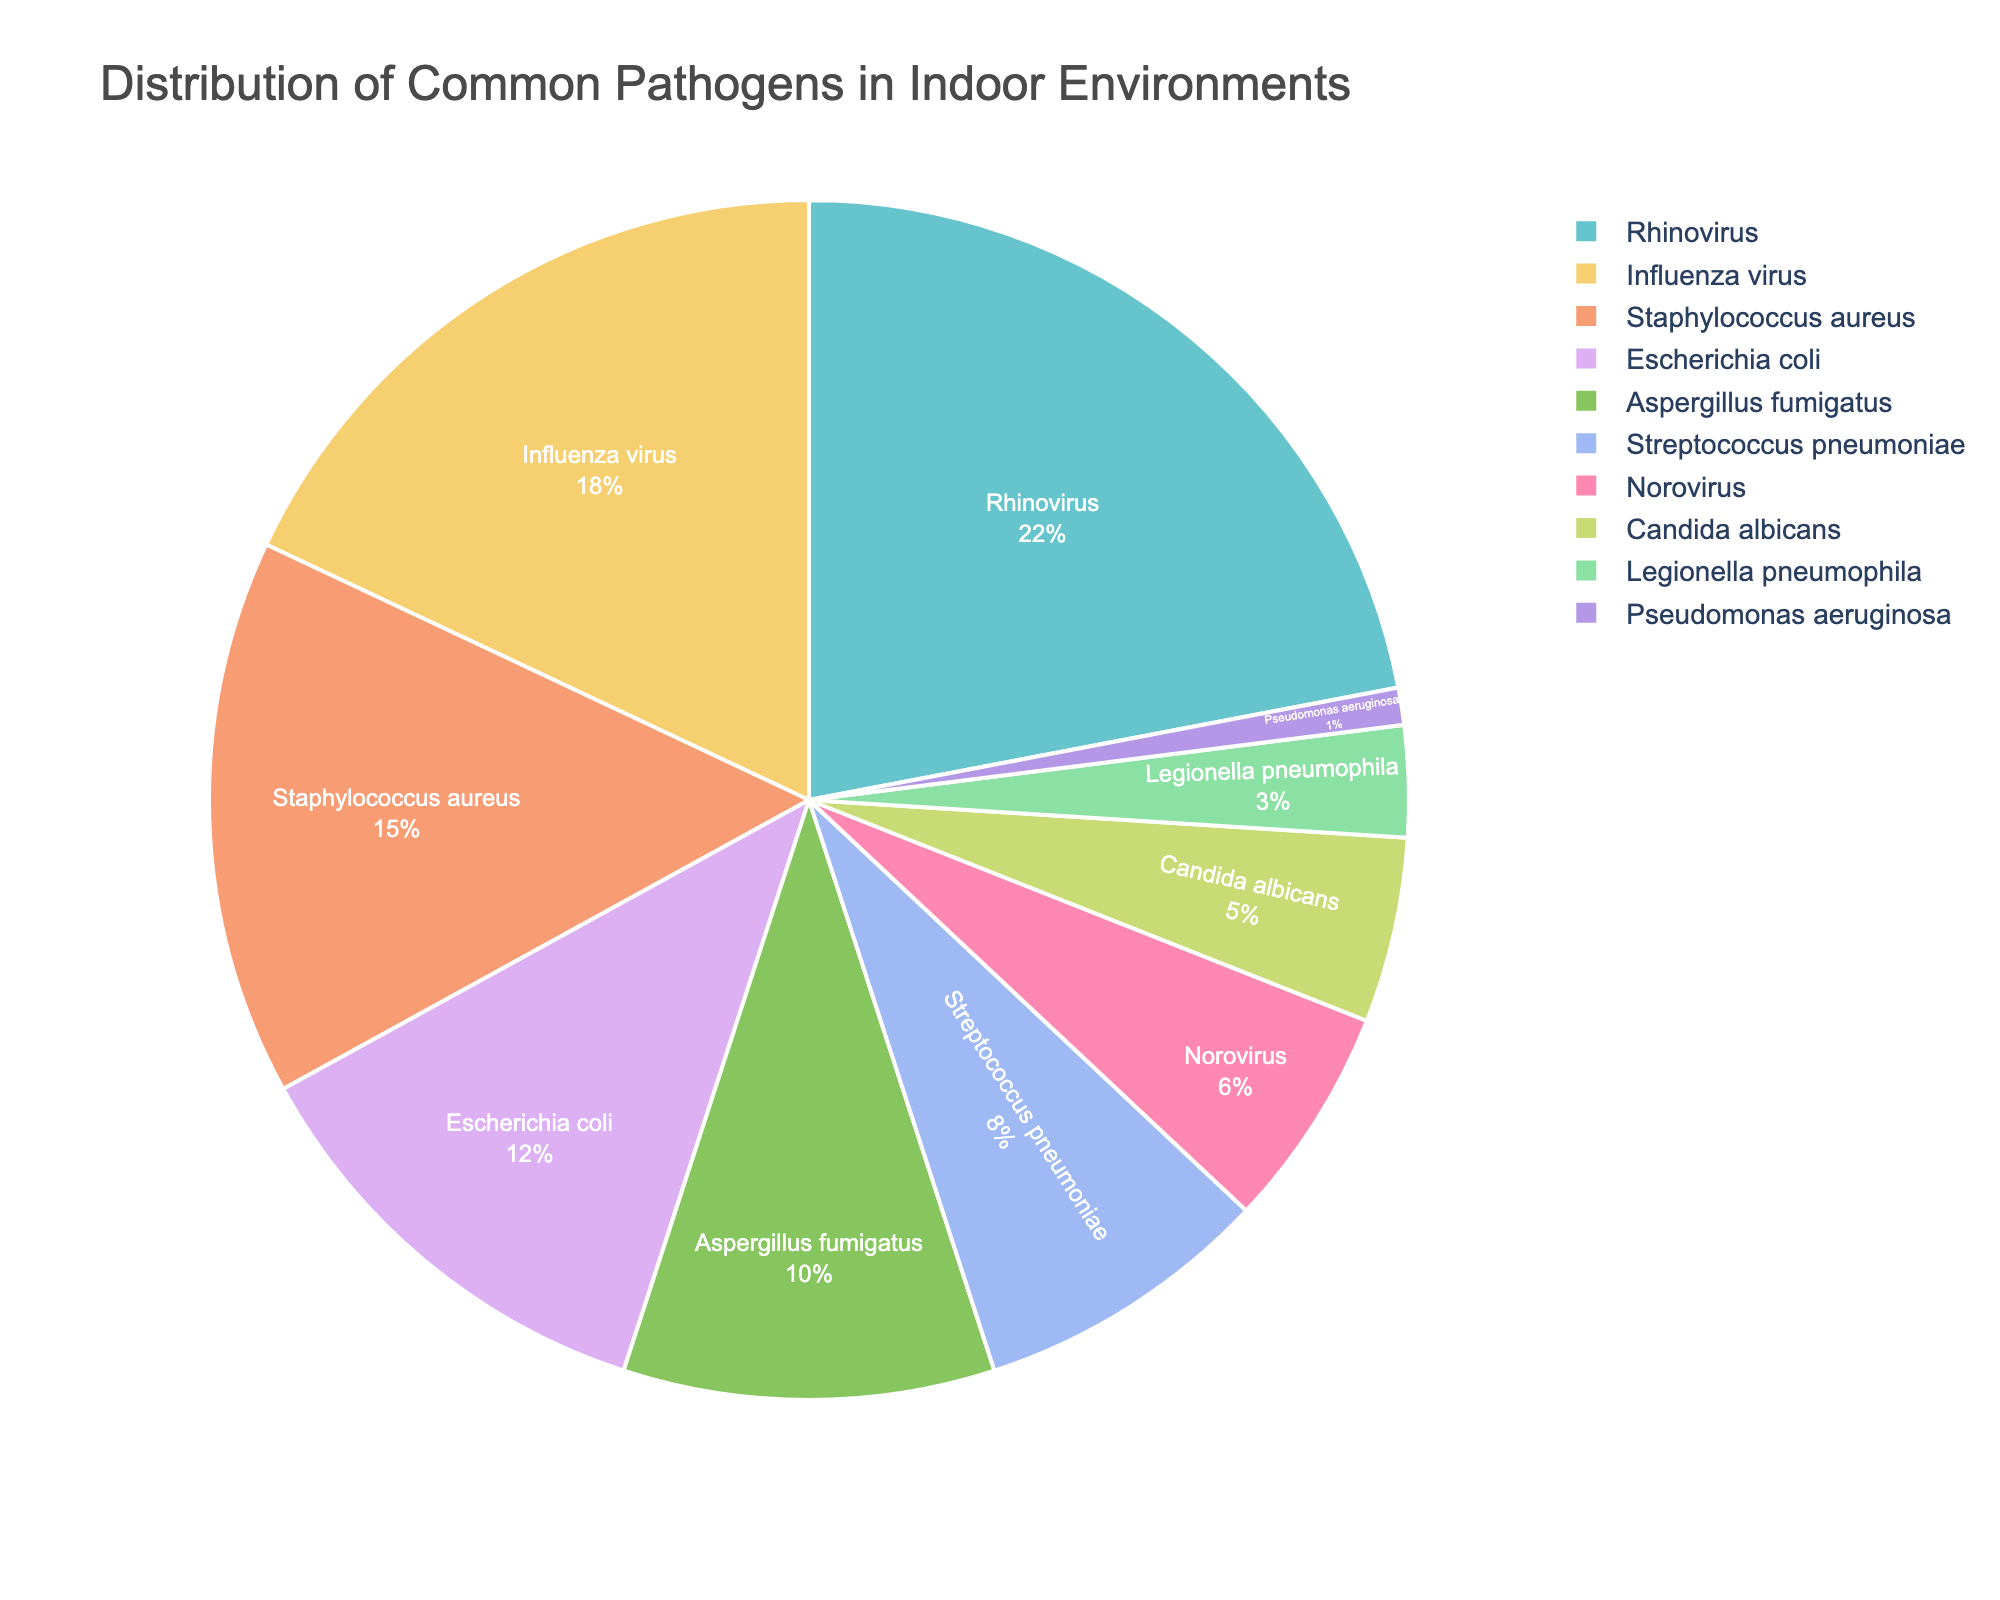Which pathogen is most common in indoor environments? The pie chart shows each pathogen's percentage. The largest section is labeled "Rhinovirus" with 22%.
Answer: Rhinovirus What is the combined percentage of Influenza virus and Rhinovirus? Check the percentages for both. Influenza virus is 18% and Rhinovirus is 22%. Add them: 22% + 18% = 40%.
Answer: 40% Which pathogens collectively make up more than 50% of the pathogens in indoor environments? Identify pathogens with the highest percentages and sum them until the total exceeds 50%. The largest three are Rhinovirus (22%), Influenza virus (18%), and Staphylococcus aureus (15%). Summing these: 22% + 18% + 15% = 55%.
Answer: Rhinovirus, Influenza virus, Staphylococcus aureus Is Escherichia coli more or less common than Streptococcus pneumoniae? Compare their percentages from the chart. Escherichia coli is 12% and Streptococcus pneumoniae is 8%.
Answer: More common What is the difference in percentage between Aspergillus fumigatus and Norovirus? Aspergillus fumigatus is 10% and Norovirus is 6%. Subtract the smaller from the larger: 10% - 6% = 4%.
Answer: 4% What proportion of the pathogens are viruses? Identify the viruses and sum their percentages. Rhinovirus (22%), Influenza virus (18%), and Norovirus (6%) are all viruses. Sum: 22% + 18% + 6% = 46%.
Answer: 46% Which pathogen is the least common in indoor environments? The pie chart shows the smallest section is labeled "Pseudomonas aeruginosa" with 1%.
Answer: Pseudomonas aeruginosa How does the proportion of bacterial pathogens compare to fungal pathogens? Identify and sum percentages of bacterial and fungal pathogens. Bacteria: Staphylococcus aureus (15%), Escherichia coli (12%), Streptococcus pneumoniae (8%), and Legionella pneumophila (3%) total 15% + 12% + 8% + 3% = 38%. Fungi: Aspergillus fumigatus (10%), Candida albicans (5%) total 10% + 5% = 15%.
Answer: Bacterial pathogens are more common than fungal pathogens 